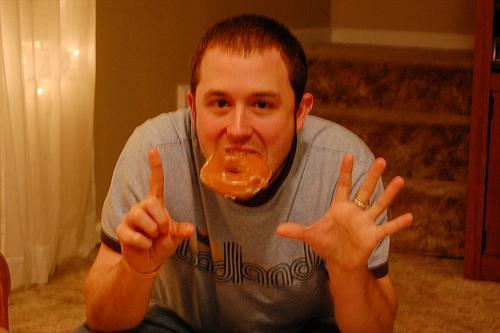How many steps are behind him?
Give a very brief answer. 3. 